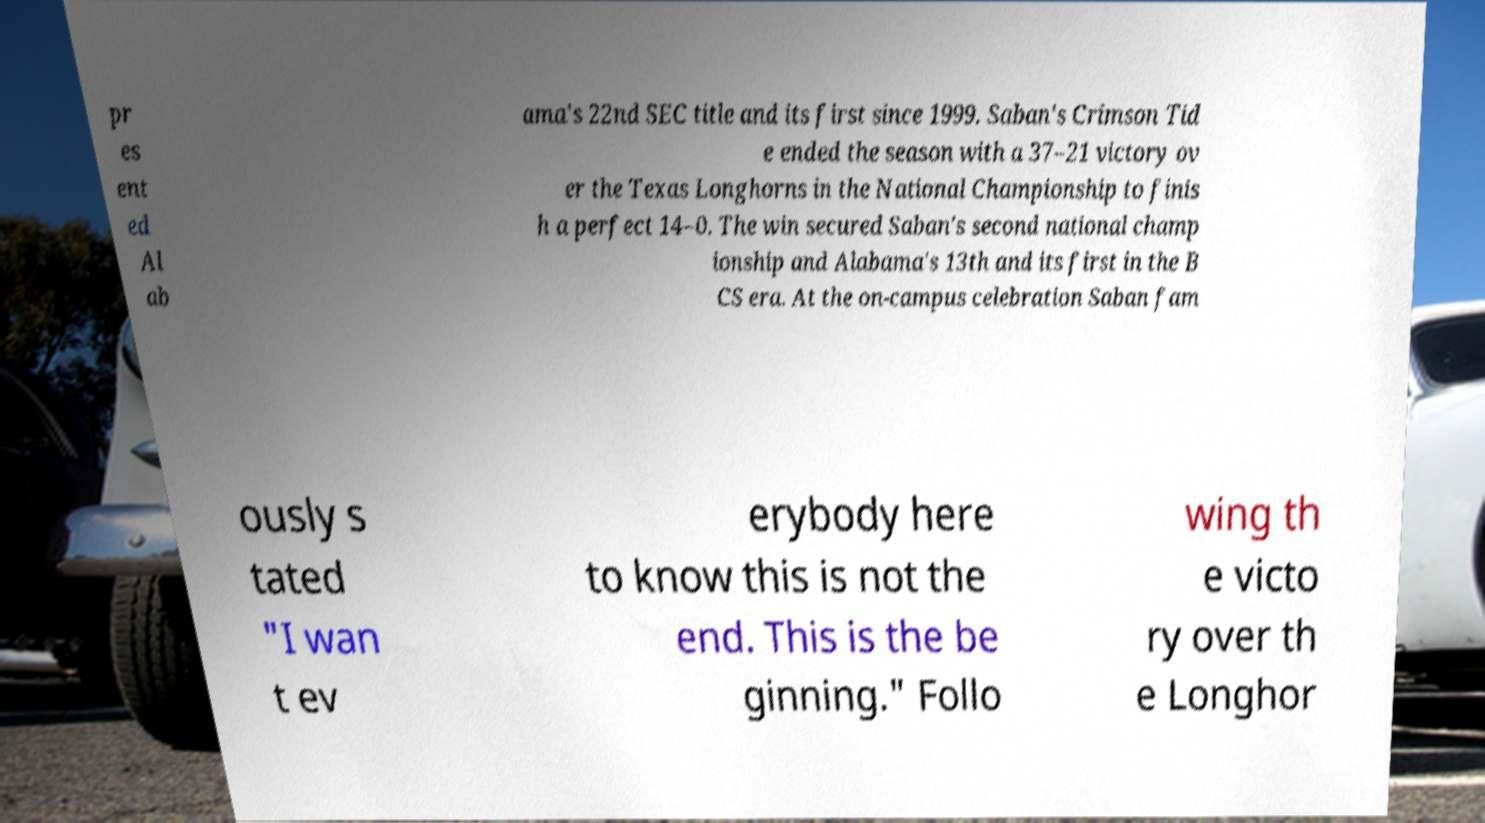There's text embedded in this image that I need extracted. Can you transcribe it verbatim? pr es ent ed Al ab ama's 22nd SEC title and its first since 1999. Saban's Crimson Tid e ended the season with a 37–21 victory ov er the Texas Longhorns in the National Championship to finis h a perfect 14–0. The win secured Saban's second national champ ionship and Alabama's 13th and its first in the B CS era. At the on-campus celebration Saban fam ously s tated "I wan t ev erybody here to know this is not the end. This is the be ginning." Follo wing th e victo ry over th e Longhor 